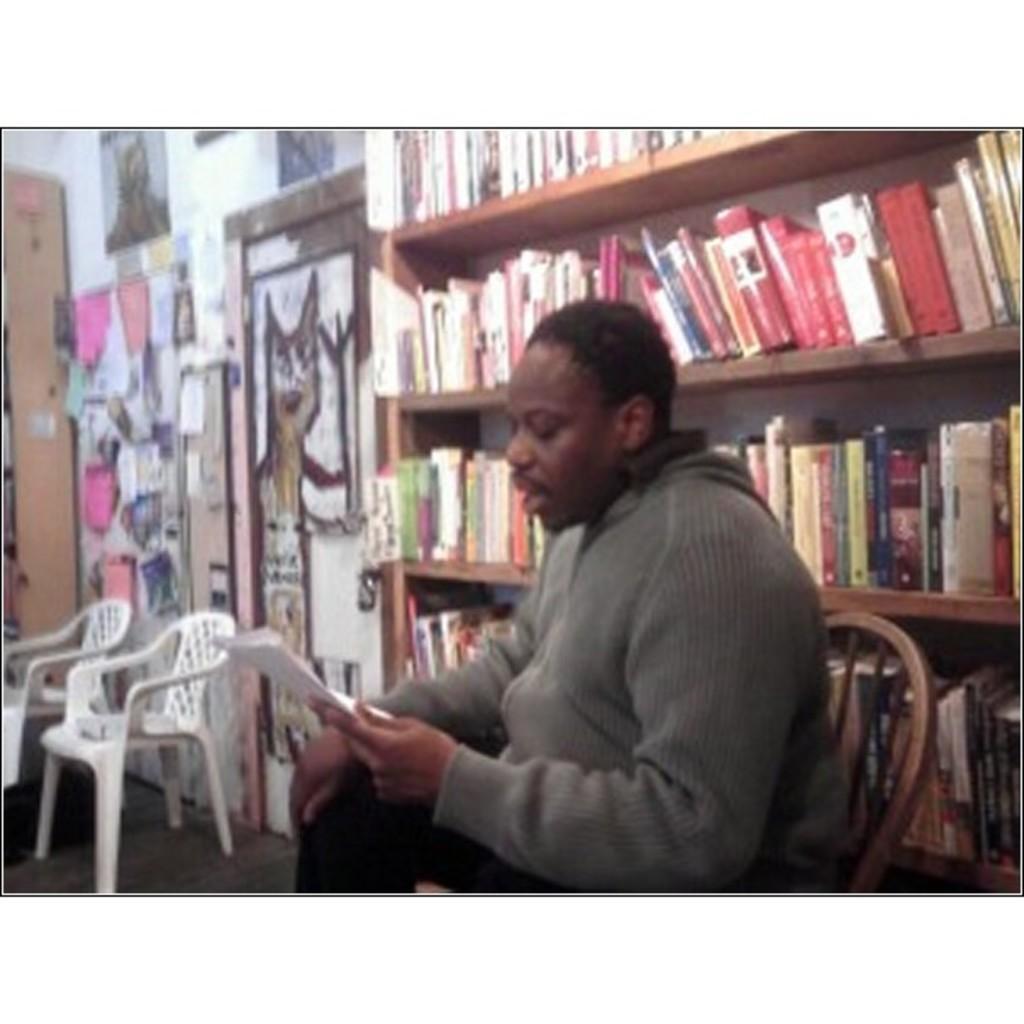Please provide a concise description of this image. In the middle of the image a man is sitting and holding a paper and reading. Behind him there is a bookshelf. Bottom left side of the image there two chairs. 